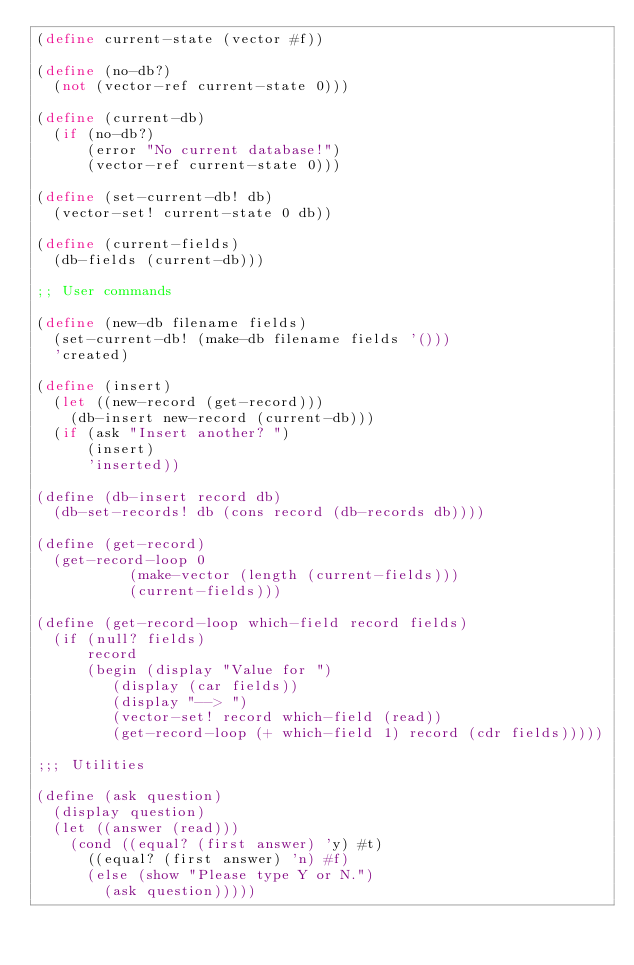<code> <loc_0><loc_0><loc_500><loc_500><_Scheme_>(define current-state (vector #f))

(define (no-db?)
  (not (vector-ref current-state 0)))

(define (current-db)
  (if (no-db?)
      (error "No current database!")
      (vector-ref current-state 0)))

(define (set-current-db! db)
  (vector-set! current-state 0 db))

(define (current-fields)
  (db-fields (current-db)))

;; User commands

(define (new-db filename fields)
  (set-current-db! (make-db filename fields '()))
  'created)

(define (insert)
  (let ((new-record (get-record)))
    (db-insert new-record (current-db)))
  (if (ask "Insert another? ")
      (insert)
      'inserted))

(define (db-insert record db)
  (db-set-records! db (cons record (db-records db))))

(define (get-record)
  (get-record-loop 0
		   (make-vector (length (current-fields)))
		   (current-fields)))

(define (get-record-loop which-field record fields)
  (if (null? fields)
      record
      (begin (display "Value for ")
	     (display (car fields))
	     (display "--> ")
	     (vector-set! record which-field (read))
	     (get-record-loop (+ which-field 1) record (cdr fields)))))

;;; Utilities

(define (ask question)
  (display question)
  (let ((answer (read)))
    (cond ((equal? (first answer) 'y) #t)
	  ((equal? (first answer) 'n) #f)
	  (else (show "Please type Y or N.")
		(ask question)))))
</code> 